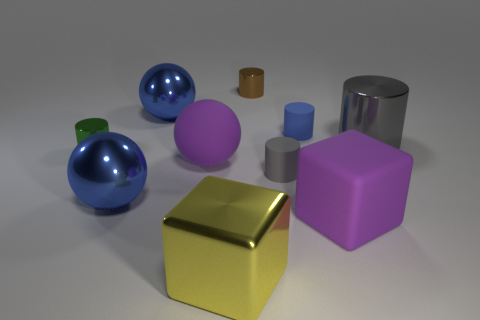What number of things are big blue rubber balls or gray objects?
Your answer should be compact. 2. There is a metallic cylinder that is in front of the small brown metallic thing and right of the large yellow block; how big is it?
Offer a very short reply. Large. How many small cylinders have the same material as the big gray object?
Make the answer very short. 2. There is a large cylinder that is the same material as the large yellow block; what is its color?
Offer a terse response. Gray. There is a small matte cylinder that is in front of the green metallic object; does it have the same color as the matte ball?
Keep it short and to the point. No. There is a large cube in front of the large purple rubber block; what is its material?
Your response must be concise. Metal. Are there an equal number of gray rubber cylinders that are on the left side of the green thing and small blue cylinders?
Offer a terse response. No. How many small objects have the same color as the large metallic cylinder?
Your response must be concise. 1. What color is the big metal thing that is the same shape as the tiny brown shiny thing?
Give a very brief answer. Gray. Do the green object and the brown cylinder have the same size?
Ensure brevity in your answer.  Yes. 